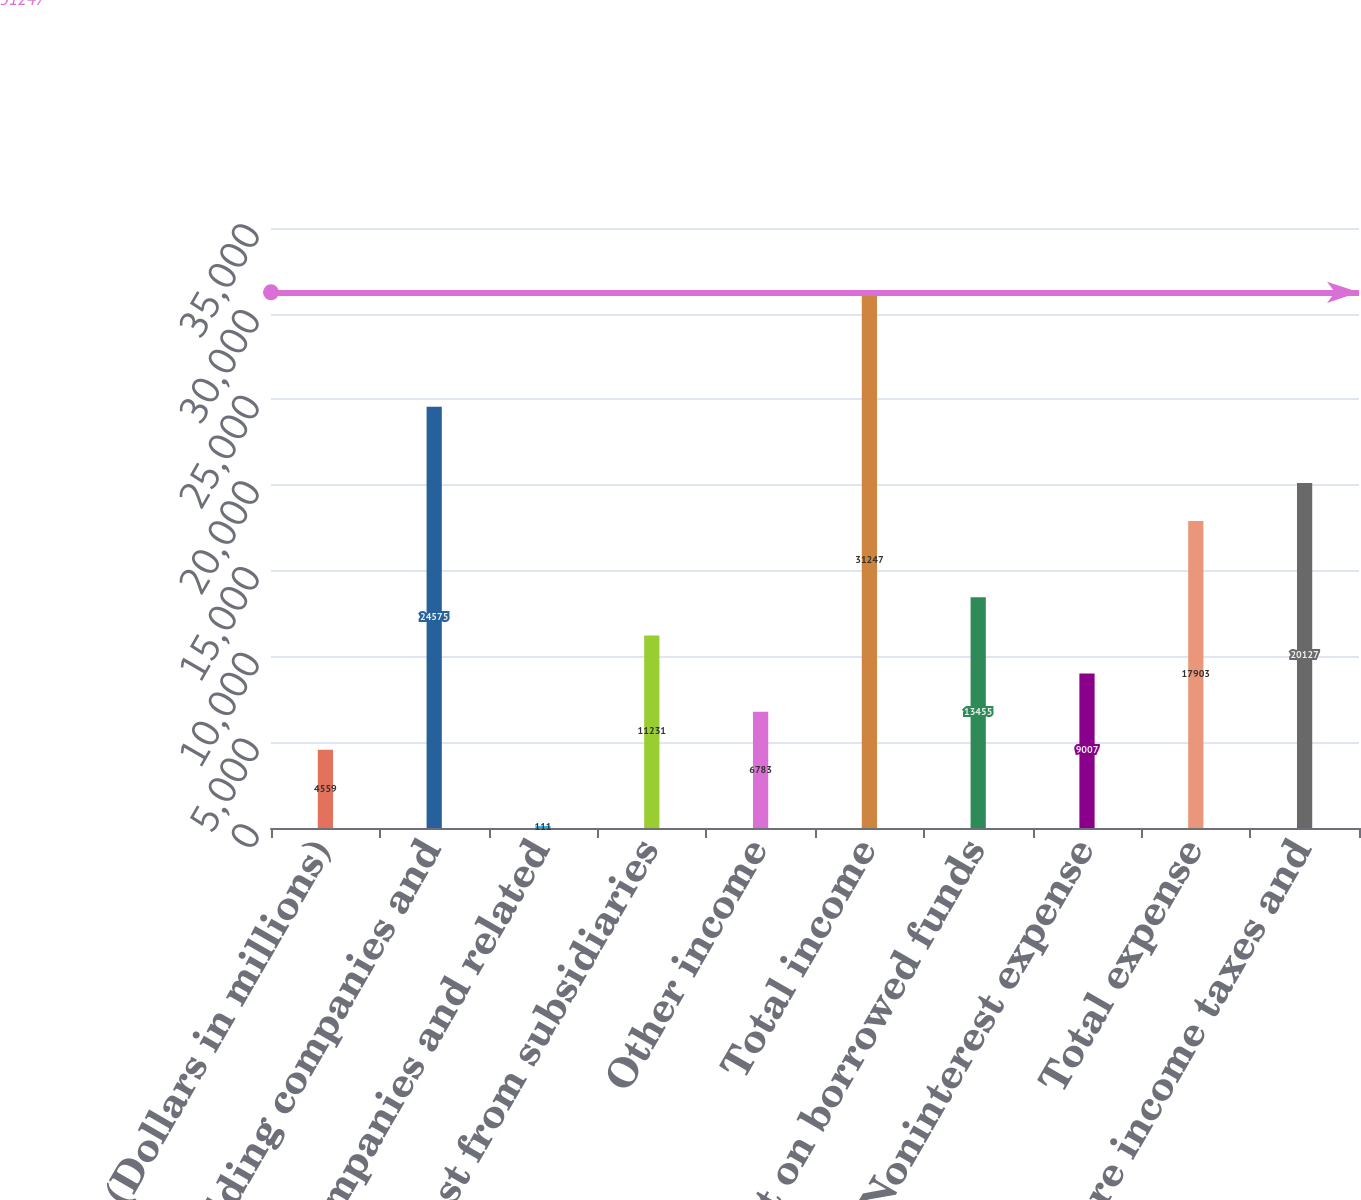Convert chart to OTSL. <chart><loc_0><loc_0><loc_500><loc_500><bar_chart><fcel>(Dollars in millions)<fcel>Bank holding companies and<fcel>Nonbank companies and related<fcel>Interest from subsidiaries<fcel>Other income<fcel>Total income<fcel>Interest on borrowed funds<fcel>Noninterest expense<fcel>Total expense<fcel>Income before income taxes and<nl><fcel>4559<fcel>24575<fcel>111<fcel>11231<fcel>6783<fcel>31247<fcel>13455<fcel>9007<fcel>17903<fcel>20127<nl></chart> 